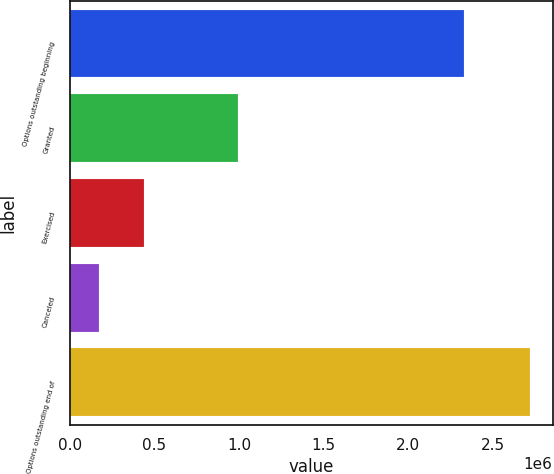Convert chart to OTSL. <chart><loc_0><loc_0><loc_500><loc_500><bar_chart><fcel>Options outstanding beginning<fcel>Granted<fcel>Exercised<fcel>Canceled<fcel>Options outstanding end of<nl><fcel>2.33046e+06<fcel>996289<fcel>438893<fcel>171077<fcel>2.71678e+06<nl></chart> 